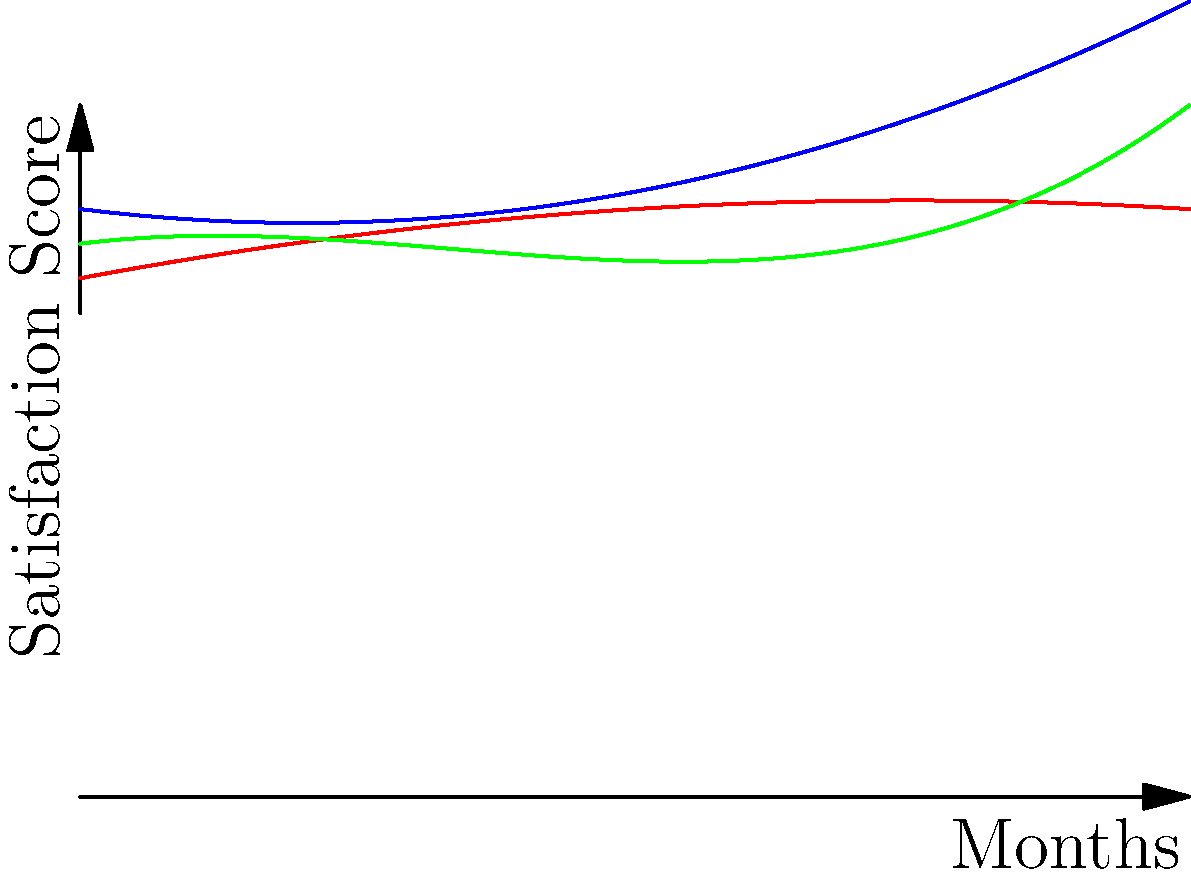As an occupational therapist working with prosthetic patients, you've been tracking patient satisfaction scores over time for three different prosthetic interventions (A, B, and C). The graph shows polynomial regression curves fitting the data for each intervention over a 10-month period. Based on the curves, which intervention appears to have the highest patient satisfaction scores at the end of the 10-month period? To determine which intervention has the highest patient satisfaction scores at the end of the 10-month period, we need to compare the values of the three curves at x = 10 (representing 10 months):

1. Analyze the curves:
   - Intervention A (blue): Quadratic curve, increasing towards the end
   - Intervention B (red): Quadratic curve, leveling off towards the end
   - Intervention C (green): Cubic curve, increasing sharply towards the end

2. Visually compare the endpoints:
   At x = 10, the green curve (Intervention C) appears to be higher than both the blue (Intervention A) and red (Intervention B) curves.

3. Confirm the visual assessment:
   The green curve (Intervention C) shows a sharp increase in the latter months, surpassing both other interventions by the 10-month mark.

4. Consider the implications:
   This suggests that Intervention C may have a more positive long-term impact on patient satisfaction, possibly due to patients becoming more comfortable with the prosthetic or experiencing improved functionality over time.

Based on this analysis, Intervention C appears to have the highest patient satisfaction scores at the end of the 10-month period.
Answer: Intervention C 